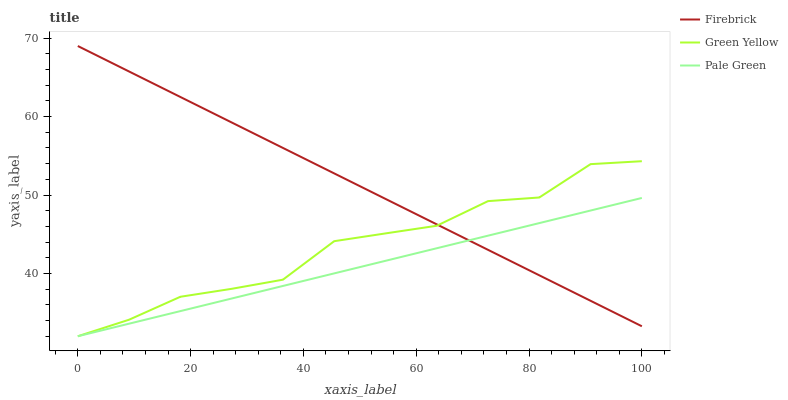Does Pale Green have the minimum area under the curve?
Answer yes or no. Yes. Does Firebrick have the maximum area under the curve?
Answer yes or no. Yes. Does Green Yellow have the minimum area under the curve?
Answer yes or no. No. Does Green Yellow have the maximum area under the curve?
Answer yes or no. No. Is Pale Green the smoothest?
Answer yes or no. Yes. Is Green Yellow the roughest?
Answer yes or no. Yes. Is Firebrick the smoothest?
Answer yes or no. No. Is Firebrick the roughest?
Answer yes or no. No. Does Firebrick have the lowest value?
Answer yes or no. No. Does Firebrick have the highest value?
Answer yes or no. Yes. Does Green Yellow have the highest value?
Answer yes or no. No. Does Green Yellow intersect Firebrick?
Answer yes or no. Yes. Is Green Yellow less than Firebrick?
Answer yes or no. No. Is Green Yellow greater than Firebrick?
Answer yes or no. No. 